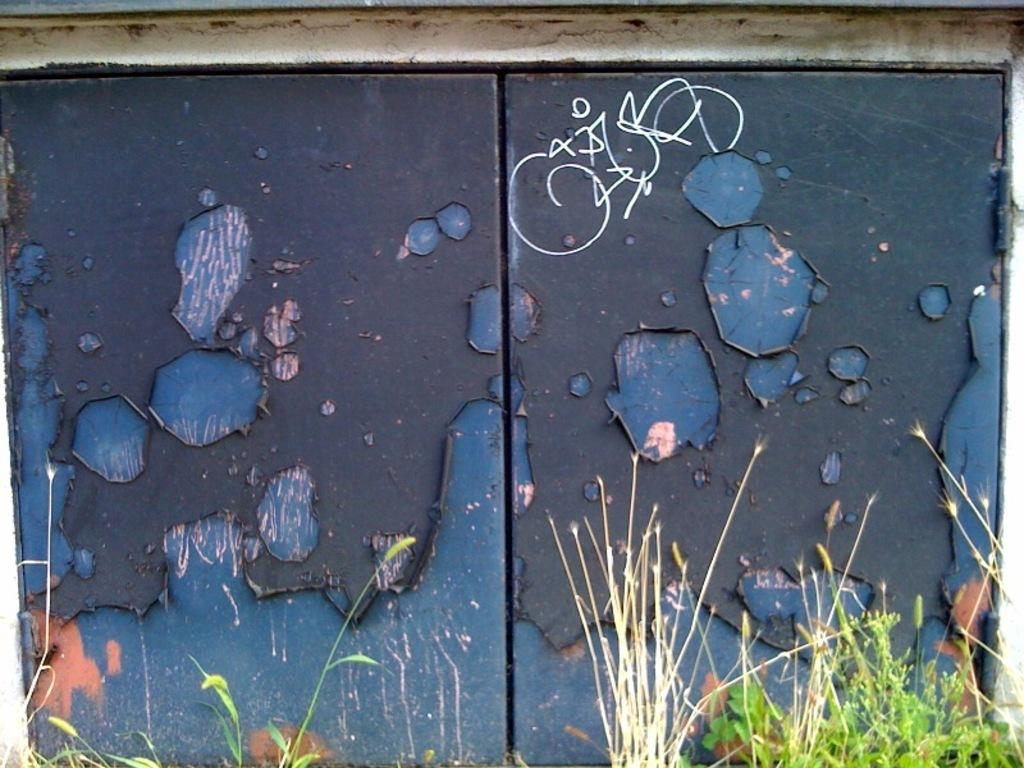What is the main object in the image? There is a door in the image. What color is the door? The door is blue. What type of vegetation can be seen at the bottom of the image? Green leaves and tiny plants are visible at the bottom portion of the image. How many records are stacked on top of the door in the image? There are no records present in the image. Are there any scissors visible near the plants at the bottom of the image? There are no scissors visible in the image. 